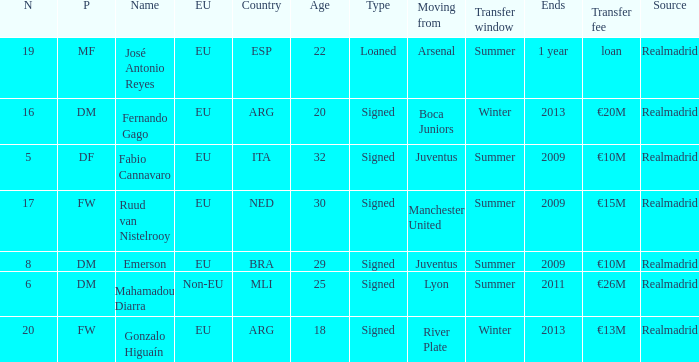How many numbers are ending in 1 year? 1.0. 